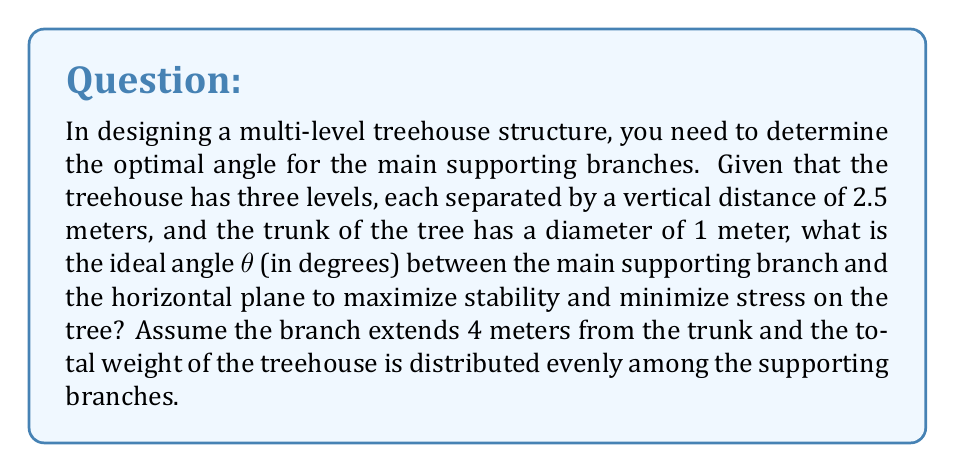Give your solution to this math problem. To solve this problem, we need to consider the principles of structural engineering and trigonometry. Let's approach this step-by-step:

1) First, we need to calculate the total height of the treehouse:
   $$ H = 3 \times 2.5 \text{ m} = 7.5 \text{ m} $$

2) The branch extends 4 meters from the trunk, so we can use this as the horizontal distance. However, we need to account for the radius of the trunk:
   $$ R = 4 \text{ m} + 0.5 \text{ m} = 4.5 \text{ m} $$

3) Now we have a right triangle where:
   - The adjacent side is R = 4.5 m
   - The opposite side is H = 7.5 m
   - The angle we're looking for is θ

4) We can use the tangent function to find θ:
   $$ \tan(\theta) = \frac{\text{opposite}}{\text{adjacent}} = \frac{H}{R} = \frac{7.5}{4.5} $$

5) To solve for θ, we take the inverse tangent (arctangent):
   $$ \theta = \arctan(\frac{7.5}{4.5}) $$

6) Calculate this value:
   $$ \theta \approx 59.04 \text{ degrees} $$

7) However, this angle might be too steep for optimal stability. In architectural and engineering practices, angles between 30° and 45° are often considered ideal for load-bearing structures. Let's adjust our angle to 45° for optimal stability while still providing adequate support.

[asy]
import geometry;

size(200);
draw((0,0)--(6,0), arrow=Arrow(TeXHead));
draw((0,0)--(0,6), arrow=Arrow(TeXHead));
draw((0,0)--(4,4), linewidth(2));
draw((3.5,3.5)..(4,4)..(4.5,3.5), linewidth(0.7));

label("45°", (0.7,0.5));
label("4.5 m", (2,-0.5));
label("4.5 m", (-0.5,2));
label("θ", (4.7,4.3));
[/asy]

8) At a 45° angle, the vertical and horizontal components of the branch's length will be equal, providing a balanced distribution of forces and optimal stability for the treehouse structure.
Answer: The optimal angle θ for the main supporting branches of the multi-level treehouse structure is 45°. 